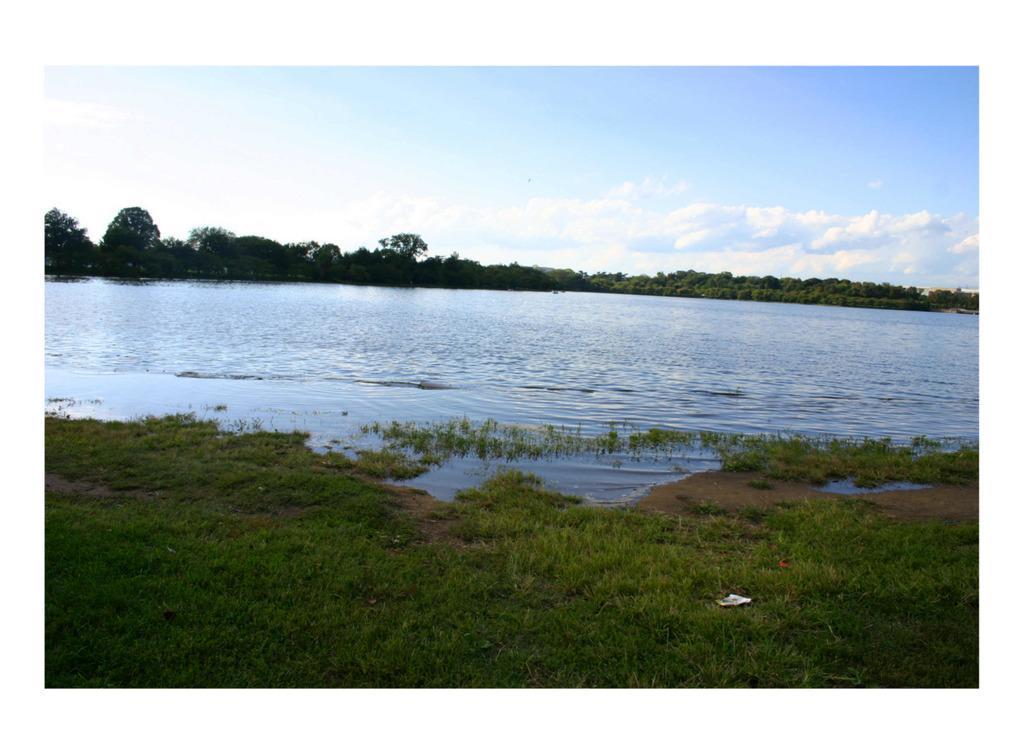In one or two sentences, can you explain what this image depicts? In this image I can see few trees,water and green grass. The sky is in white and blue color. 